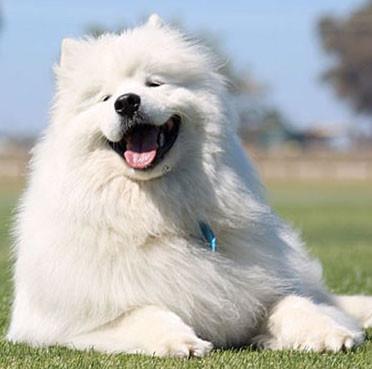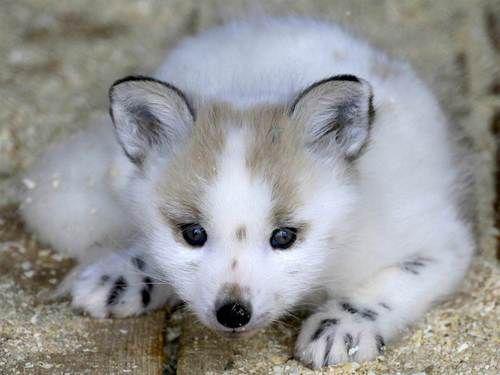The first image is the image on the left, the second image is the image on the right. Analyze the images presented: Is the assertion "Exactly two large white dogs are shown in snowy outdoor areas with trees in the background, one of them wearing a harness." valid? Answer yes or no. No. The first image is the image on the left, the second image is the image on the right. Assess this claim about the two images: "An image shows a white dog wearing a harness in a wintry scene.". Correct or not? Answer yes or no. No. 